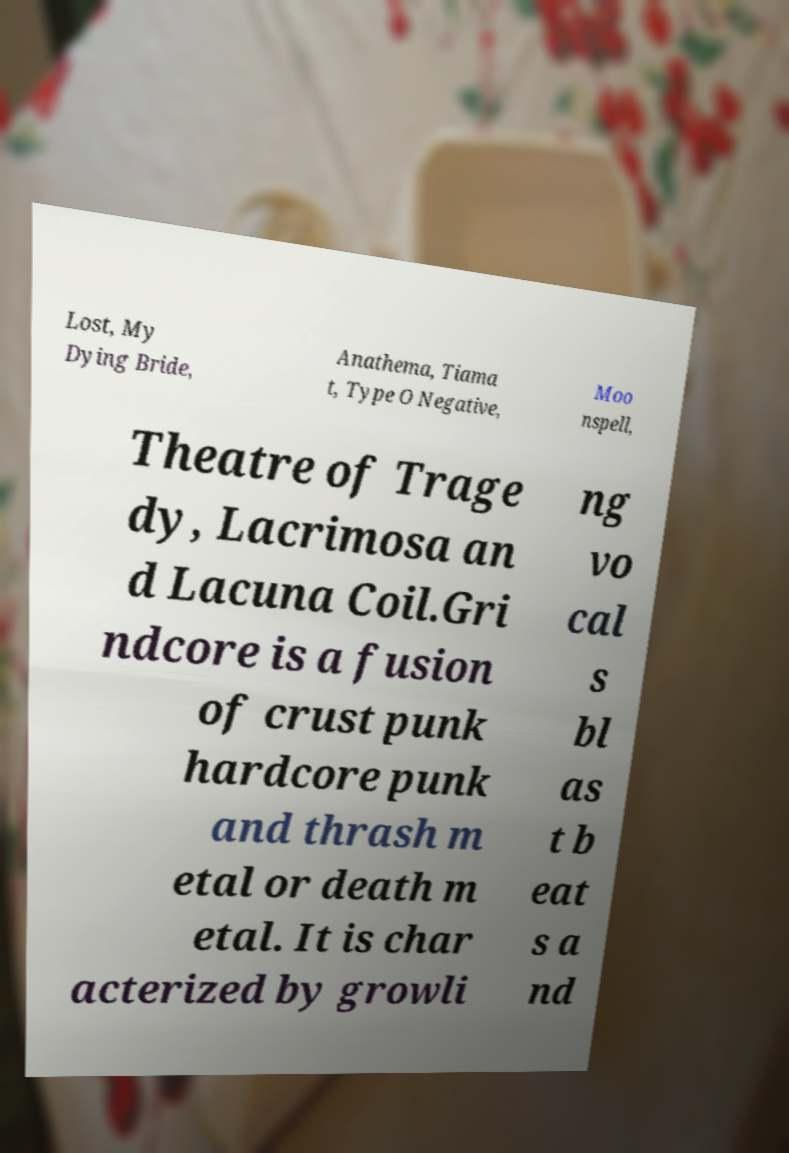Can you read and provide the text displayed in the image?This photo seems to have some interesting text. Can you extract and type it out for me? Lost, My Dying Bride, Anathema, Tiama t, Type O Negative, Moo nspell, Theatre of Trage dy, Lacrimosa an d Lacuna Coil.Gri ndcore is a fusion of crust punk hardcore punk and thrash m etal or death m etal. It is char acterized by growli ng vo cal s bl as t b eat s a nd 